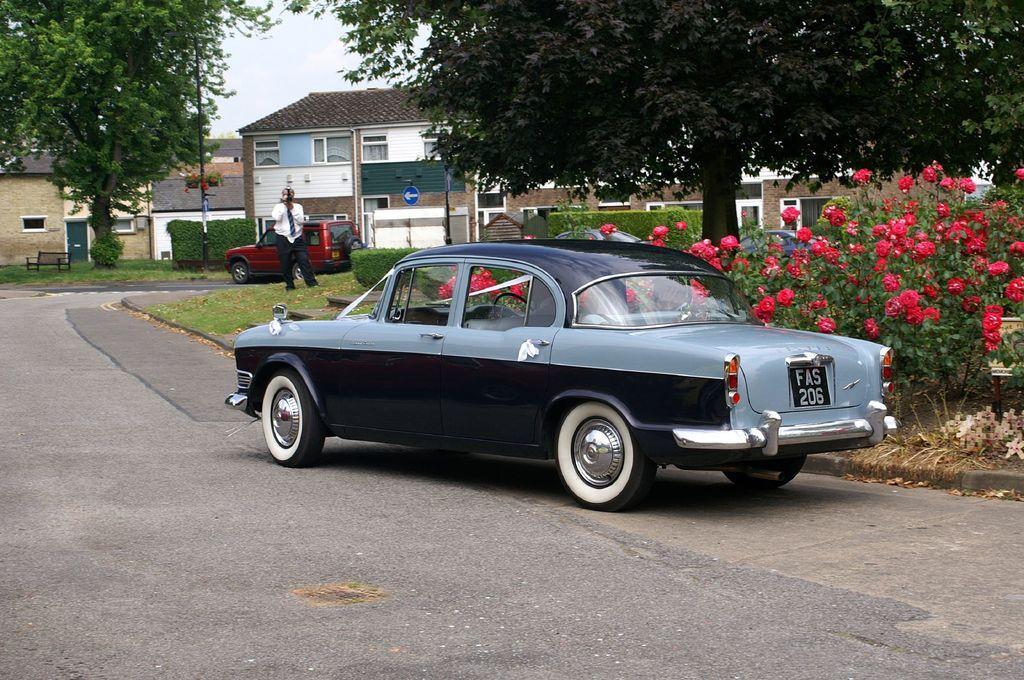How would you summarize this image in a sentence or two? A black color car is there on the road, on the right side there are red color flower plants. In the middle there are houses. On the left side there is a tree. 